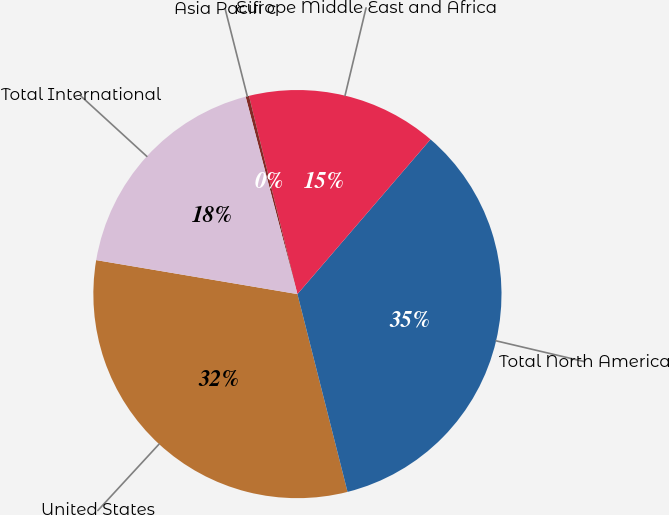Convert chart to OTSL. <chart><loc_0><loc_0><loc_500><loc_500><pie_chart><fcel>United States<fcel>Total North America<fcel>Europe Middle East and Africa<fcel>Asia Pacifi c<fcel>Total International<nl><fcel>31.61%<fcel>34.74%<fcel>15.12%<fcel>0.27%<fcel>18.25%<nl></chart> 